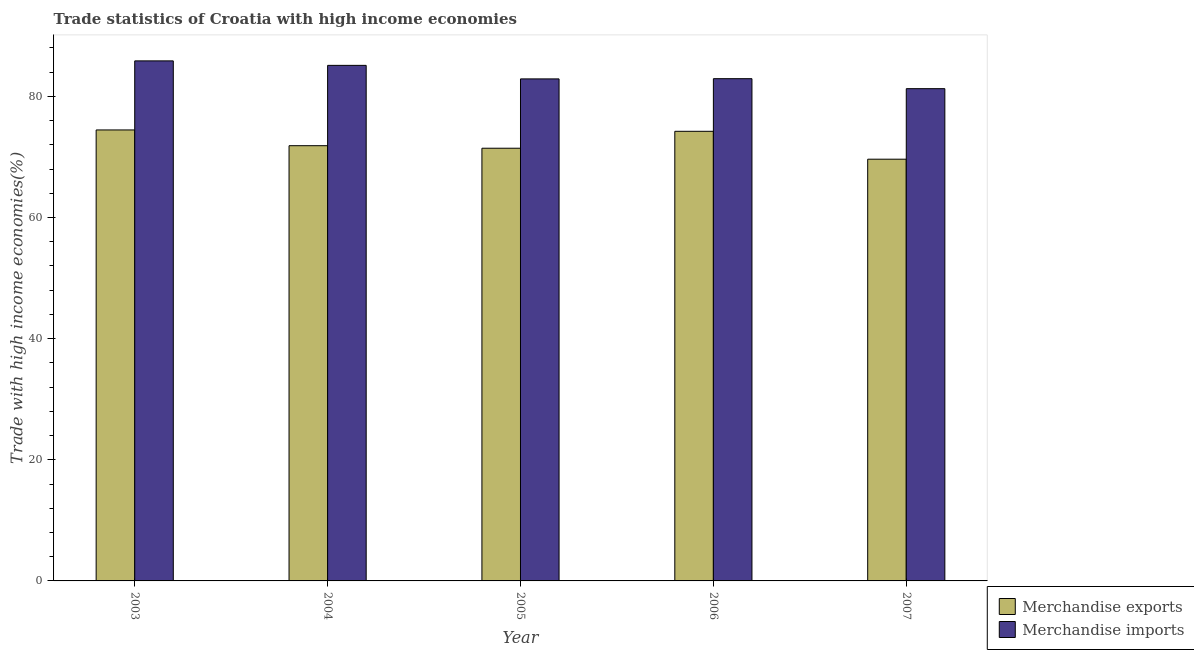Are the number of bars per tick equal to the number of legend labels?
Provide a short and direct response. Yes. How many bars are there on the 1st tick from the left?
Offer a terse response. 2. What is the label of the 2nd group of bars from the left?
Give a very brief answer. 2004. In how many cases, is the number of bars for a given year not equal to the number of legend labels?
Provide a short and direct response. 0. What is the merchandise exports in 2007?
Provide a short and direct response. 69.62. Across all years, what is the maximum merchandise exports?
Ensure brevity in your answer.  74.45. Across all years, what is the minimum merchandise imports?
Offer a very short reply. 81.27. What is the total merchandise exports in the graph?
Ensure brevity in your answer.  361.59. What is the difference between the merchandise imports in 2004 and that in 2005?
Offer a very short reply. 2.23. What is the difference between the merchandise exports in 2003 and the merchandise imports in 2004?
Provide a succinct answer. 2.6. What is the average merchandise exports per year?
Provide a short and direct response. 72.32. In the year 2003, what is the difference between the merchandise exports and merchandise imports?
Ensure brevity in your answer.  0. In how many years, is the merchandise exports greater than 16 %?
Make the answer very short. 5. What is the ratio of the merchandise exports in 2003 to that in 2004?
Offer a terse response. 1.04. What is the difference between the highest and the second highest merchandise imports?
Your answer should be compact. 0.74. What is the difference between the highest and the lowest merchandise exports?
Make the answer very short. 4.83. Is the sum of the merchandise exports in 2003 and 2007 greater than the maximum merchandise imports across all years?
Offer a very short reply. Yes. What does the 1st bar from the left in 2003 represents?
Provide a short and direct response. Merchandise exports. What is the difference between two consecutive major ticks on the Y-axis?
Your answer should be very brief. 20. Are the values on the major ticks of Y-axis written in scientific E-notation?
Your answer should be compact. No. Does the graph contain any zero values?
Give a very brief answer. No. Does the graph contain grids?
Keep it short and to the point. No. How many legend labels are there?
Provide a succinct answer. 2. How are the legend labels stacked?
Offer a terse response. Vertical. What is the title of the graph?
Offer a terse response. Trade statistics of Croatia with high income economies. Does "Manufacturing industries and construction" appear as one of the legend labels in the graph?
Make the answer very short. No. What is the label or title of the Y-axis?
Ensure brevity in your answer.  Trade with high income economies(%). What is the Trade with high income economies(%) of Merchandise exports in 2003?
Offer a very short reply. 74.45. What is the Trade with high income economies(%) in Merchandise imports in 2003?
Make the answer very short. 85.85. What is the Trade with high income economies(%) in Merchandise exports in 2004?
Your answer should be very brief. 71.85. What is the Trade with high income economies(%) in Merchandise imports in 2004?
Provide a succinct answer. 85.11. What is the Trade with high income economies(%) in Merchandise exports in 2005?
Give a very brief answer. 71.44. What is the Trade with high income economies(%) in Merchandise imports in 2005?
Offer a very short reply. 82.88. What is the Trade with high income economies(%) in Merchandise exports in 2006?
Provide a short and direct response. 74.23. What is the Trade with high income economies(%) in Merchandise imports in 2006?
Give a very brief answer. 82.92. What is the Trade with high income economies(%) in Merchandise exports in 2007?
Your response must be concise. 69.62. What is the Trade with high income economies(%) in Merchandise imports in 2007?
Offer a very short reply. 81.27. Across all years, what is the maximum Trade with high income economies(%) of Merchandise exports?
Your answer should be compact. 74.45. Across all years, what is the maximum Trade with high income economies(%) of Merchandise imports?
Make the answer very short. 85.85. Across all years, what is the minimum Trade with high income economies(%) of Merchandise exports?
Provide a short and direct response. 69.62. Across all years, what is the minimum Trade with high income economies(%) in Merchandise imports?
Make the answer very short. 81.27. What is the total Trade with high income economies(%) of Merchandise exports in the graph?
Provide a short and direct response. 361.59. What is the total Trade with high income economies(%) in Merchandise imports in the graph?
Provide a short and direct response. 418.03. What is the difference between the Trade with high income economies(%) in Merchandise exports in 2003 and that in 2004?
Provide a succinct answer. 2.6. What is the difference between the Trade with high income economies(%) of Merchandise imports in 2003 and that in 2004?
Give a very brief answer. 0.74. What is the difference between the Trade with high income economies(%) of Merchandise exports in 2003 and that in 2005?
Offer a very short reply. 3.02. What is the difference between the Trade with high income economies(%) of Merchandise imports in 2003 and that in 2005?
Give a very brief answer. 2.97. What is the difference between the Trade with high income economies(%) in Merchandise exports in 2003 and that in 2006?
Give a very brief answer. 0.22. What is the difference between the Trade with high income economies(%) in Merchandise imports in 2003 and that in 2006?
Your answer should be compact. 2.94. What is the difference between the Trade with high income economies(%) in Merchandise exports in 2003 and that in 2007?
Your answer should be very brief. 4.83. What is the difference between the Trade with high income economies(%) in Merchandise imports in 2003 and that in 2007?
Provide a succinct answer. 4.59. What is the difference between the Trade with high income economies(%) of Merchandise exports in 2004 and that in 2005?
Provide a short and direct response. 0.42. What is the difference between the Trade with high income economies(%) of Merchandise imports in 2004 and that in 2005?
Give a very brief answer. 2.23. What is the difference between the Trade with high income economies(%) in Merchandise exports in 2004 and that in 2006?
Give a very brief answer. -2.38. What is the difference between the Trade with high income economies(%) in Merchandise imports in 2004 and that in 2006?
Your response must be concise. 2.2. What is the difference between the Trade with high income economies(%) of Merchandise exports in 2004 and that in 2007?
Keep it short and to the point. 2.23. What is the difference between the Trade with high income economies(%) in Merchandise imports in 2004 and that in 2007?
Make the answer very short. 3.85. What is the difference between the Trade with high income economies(%) of Merchandise exports in 2005 and that in 2006?
Your answer should be very brief. -2.79. What is the difference between the Trade with high income economies(%) in Merchandise imports in 2005 and that in 2006?
Your answer should be compact. -0.04. What is the difference between the Trade with high income economies(%) of Merchandise exports in 2005 and that in 2007?
Your answer should be compact. 1.81. What is the difference between the Trade with high income economies(%) of Merchandise imports in 2005 and that in 2007?
Give a very brief answer. 1.61. What is the difference between the Trade with high income economies(%) in Merchandise exports in 2006 and that in 2007?
Offer a very short reply. 4.6. What is the difference between the Trade with high income economies(%) in Merchandise imports in 2006 and that in 2007?
Provide a short and direct response. 1.65. What is the difference between the Trade with high income economies(%) in Merchandise exports in 2003 and the Trade with high income economies(%) in Merchandise imports in 2004?
Give a very brief answer. -10.66. What is the difference between the Trade with high income economies(%) of Merchandise exports in 2003 and the Trade with high income economies(%) of Merchandise imports in 2005?
Make the answer very short. -8.43. What is the difference between the Trade with high income economies(%) of Merchandise exports in 2003 and the Trade with high income economies(%) of Merchandise imports in 2006?
Make the answer very short. -8.46. What is the difference between the Trade with high income economies(%) in Merchandise exports in 2003 and the Trade with high income economies(%) in Merchandise imports in 2007?
Provide a succinct answer. -6.81. What is the difference between the Trade with high income economies(%) in Merchandise exports in 2004 and the Trade with high income economies(%) in Merchandise imports in 2005?
Your response must be concise. -11.03. What is the difference between the Trade with high income economies(%) in Merchandise exports in 2004 and the Trade with high income economies(%) in Merchandise imports in 2006?
Offer a terse response. -11.06. What is the difference between the Trade with high income economies(%) of Merchandise exports in 2004 and the Trade with high income economies(%) of Merchandise imports in 2007?
Ensure brevity in your answer.  -9.41. What is the difference between the Trade with high income economies(%) of Merchandise exports in 2005 and the Trade with high income economies(%) of Merchandise imports in 2006?
Make the answer very short. -11.48. What is the difference between the Trade with high income economies(%) of Merchandise exports in 2005 and the Trade with high income economies(%) of Merchandise imports in 2007?
Offer a terse response. -9.83. What is the difference between the Trade with high income economies(%) in Merchandise exports in 2006 and the Trade with high income economies(%) in Merchandise imports in 2007?
Make the answer very short. -7.04. What is the average Trade with high income economies(%) of Merchandise exports per year?
Your answer should be very brief. 72.32. What is the average Trade with high income economies(%) in Merchandise imports per year?
Keep it short and to the point. 83.61. In the year 2003, what is the difference between the Trade with high income economies(%) in Merchandise exports and Trade with high income economies(%) in Merchandise imports?
Give a very brief answer. -11.4. In the year 2004, what is the difference between the Trade with high income economies(%) in Merchandise exports and Trade with high income economies(%) in Merchandise imports?
Provide a succinct answer. -13.26. In the year 2005, what is the difference between the Trade with high income economies(%) of Merchandise exports and Trade with high income economies(%) of Merchandise imports?
Make the answer very short. -11.45. In the year 2006, what is the difference between the Trade with high income economies(%) of Merchandise exports and Trade with high income economies(%) of Merchandise imports?
Give a very brief answer. -8.69. In the year 2007, what is the difference between the Trade with high income economies(%) in Merchandise exports and Trade with high income economies(%) in Merchandise imports?
Your response must be concise. -11.64. What is the ratio of the Trade with high income economies(%) in Merchandise exports in 2003 to that in 2004?
Keep it short and to the point. 1.04. What is the ratio of the Trade with high income economies(%) of Merchandise imports in 2003 to that in 2004?
Make the answer very short. 1.01. What is the ratio of the Trade with high income economies(%) of Merchandise exports in 2003 to that in 2005?
Ensure brevity in your answer.  1.04. What is the ratio of the Trade with high income economies(%) in Merchandise imports in 2003 to that in 2005?
Ensure brevity in your answer.  1.04. What is the ratio of the Trade with high income economies(%) of Merchandise exports in 2003 to that in 2006?
Offer a terse response. 1. What is the ratio of the Trade with high income economies(%) in Merchandise imports in 2003 to that in 2006?
Offer a terse response. 1.04. What is the ratio of the Trade with high income economies(%) in Merchandise exports in 2003 to that in 2007?
Keep it short and to the point. 1.07. What is the ratio of the Trade with high income economies(%) in Merchandise imports in 2003 to that in 2007?
Give a very brief answer. 1.06. What is the ratio of the Trade with high income economies(%) of Merchandise imports in 2004 to that in 2005?
Provide a succinct answer. 1.03. What is the ratio of the Trade with high income economies(%) in Merchandise exports in 2004 to that in 2006?
Offer a terse response. 0.97. What is the ratio of the Trade with high income economies(%) of Merchandise imports in 2004 to that in 2006?
Your answer should be very brief. 1.03. What is the ratio of the Trade with high income economies(%) of Merchandise exports in 2004 to that in 2007?
Provide a succinct answer. 1.03. What is the ratio of the Trade with high income economies(%) of Merchandise imports in 2004 to that in 2007?
Your response must be concise. 1.05. What is the ratio of the Trade with high income economies(%) in Merchandise exports in 2005 to that in 2006?
Make the answer very short. 0.96. What is the ratio of the Trade with high income economies(%) of Merchandise exports in 2005 to that in 2007?
Ensure brevity in your answer.  1.03. What is the ratio of the Trade with high income economies(%) of Merchandise imports in 2005 to that in 2007?
Your response must be concise. 1.02. What is the ratio of the Trade with high income economies(%) in Merchandise exports in 2006 to that in 2007?
Give a very brief answer. 1.07. What is the ratio of the Trade with high income economies(%) of Merchandise imports in 2006 to that in 2007?
Keep it short and to the point. 1.02. What is the difference between the highest and the second highest Trade with high income economies(%) in Merchandise exports?
Ensure brevity in your answer.  0.22. What is the difference between the highest and the second highest Trade with high income economies(%) in Merchandise imports?
Ensure brevity in your answer.  0.74. What is the difference between the highest and the lowest Trade with high income economies(%) of Merchandise exports?
Ensure brevity in your answer.  4.83. What is the difference between the highest and the lowest Trade with high income economies(%) of Merchandise imports?
Offer a terse response. 4.59. 